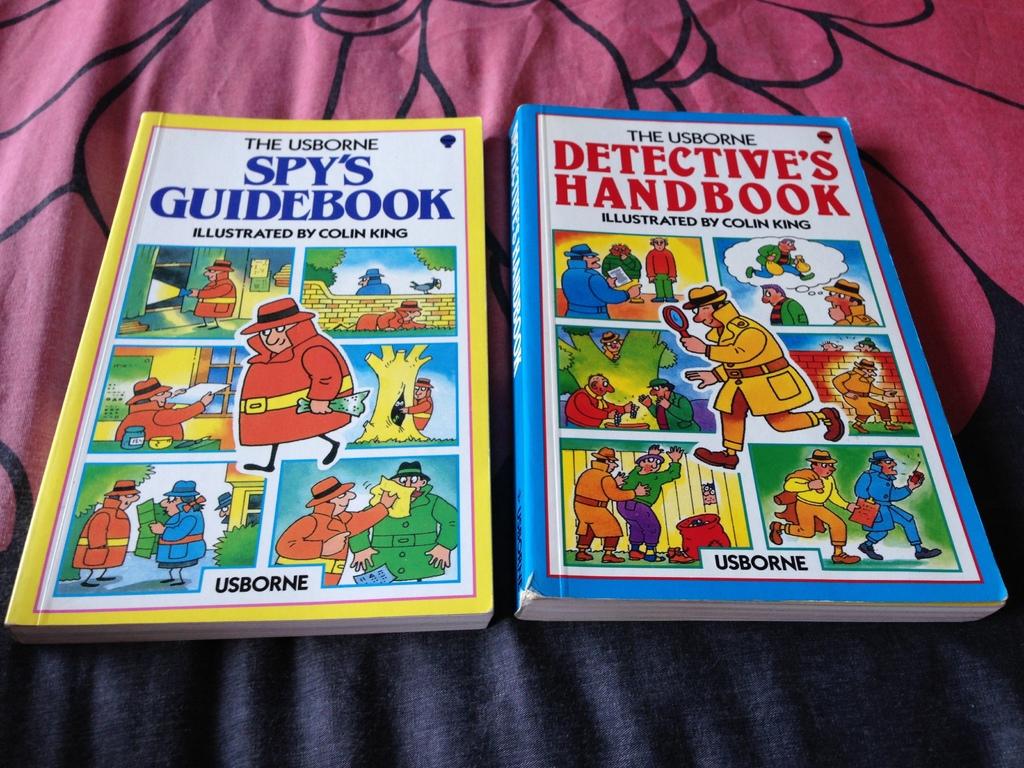What are the titles of these books?
Provide a succinct answer. Spy's guidebook and detective's handbook. Who illustrated the left book?
Your response must be concise. Colin king. 